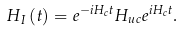<formula> <loc_0><loc_0><loc_500><loc_500>H _ { I } \left ( t \right ) = e ^ { - i H _ { c } t } H _ { u c } e ^ { i H _ { c } t } .</formula> 